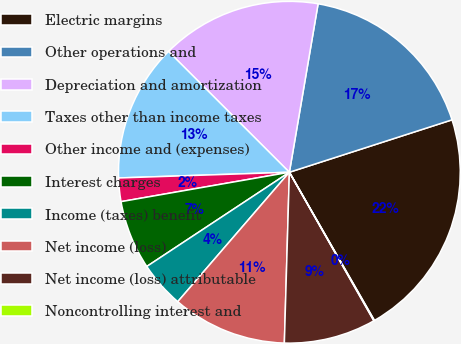Convert chart. <chart><loc_0><loc_0><loc_500><loc_500><pie_chart><fcel>Electric margins<fcel>Other operations and<fcel>Depreciation and amortization<fcel>Taxes other than income taxes<fcel>Other income and (expenses)<fcel>Interest charges<fcel>Income (taxes) benefit<fcel>Net income (loss)<fcel>Net income (loss) attributable<fcel>Noncontrolling interest and<nl><fcel>21.67%<fcel>17.35%<fcel>15.19%<fcel>13.03%<fcel>2.22%<fcel>6.54%<fcel>4.38%<fcel>10.86%<fcel>8.7%<fcel>0.06%<nl></chart> 